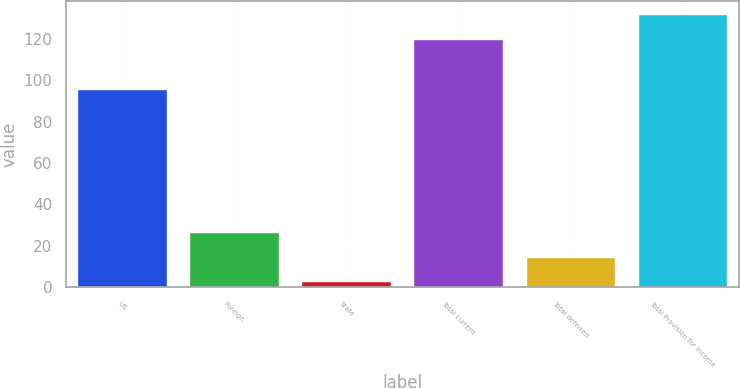Convert chart to OTSL. <chart><loc_0><loc_0><loc_500><loc_500><bar_chart><fcel>US<fcel>Foreign<fcel>State<fcel>Total current<fcel>Total deferred<fcel>Total Provision for income<nl><fcel>95.7<fcel>26.84<fcel>2.8<fcel>119.8<fcel>14.82<fcel>131.82<nl></chart> 